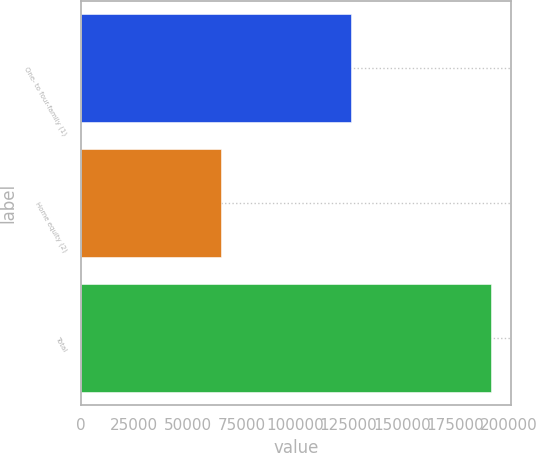<chart> <loc_0><loc_0><loc_500><loc_500><bar_chart><fcel>One- to four-family (1)<fcel>Home equity (2)<fcel>Total<nl><fcel>126172<fcel>65331<fcel>191503<nl></chart> 